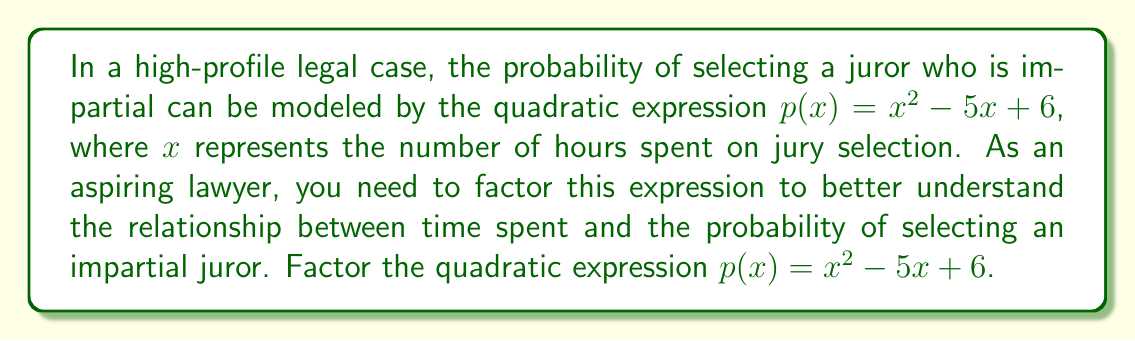Solve this math problem. To factor this quadratic expression, we'll follow these steps:

1) First, we identify that this is a quadratic expression in the form $ax^2 + bx + c$, where:
   $a = 1$
   $b = -5$
   $c = 6$

2) We need to find two numbers that multiply to give $ac = 1 \times 6 = 6$ and add up to $b = -5$.

3) The two numbers that satisfy this condition are $-2$ and $-3$:
   $(-2) \times (-3) = 6$
   $(-2) + (-3) = -5$

4) We can rewrite the middle term using these numbers:
   $p(x) = x^2 - 2x - 3x + 6$

5) Now we can factor by grouping:
   $p(x) = (x^2 - 2x) + (-3x + 6)$
   $p(x) = x(x - 2) - 3(x - 2)$

6) We can factor out the common factor $(x - 2)$:
   $p(x) = (x - 2)(x - 3)$

Thus, we have factored the quadratic expression into two linear factors.
Answer: $p(x) = (x - 2)(x - 3)$ 